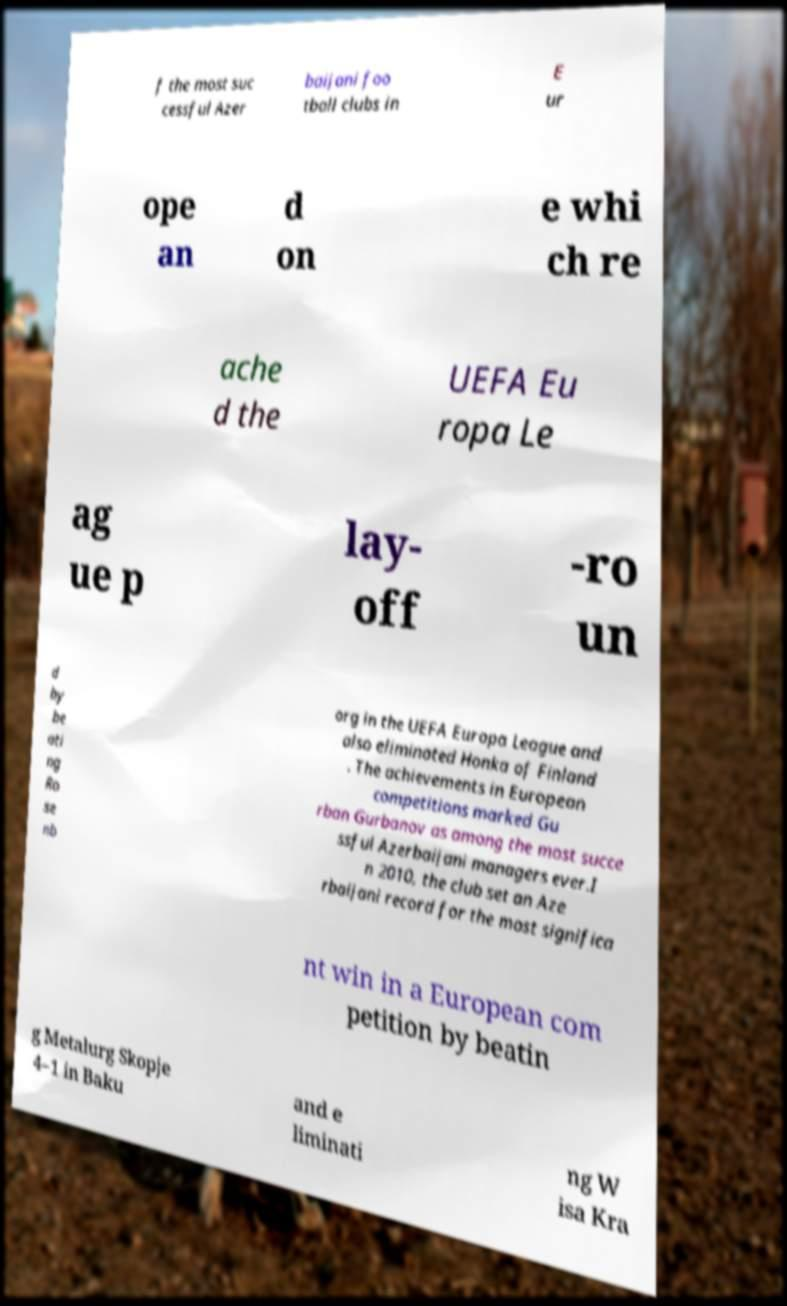For documentation purposes, I need the text within this image transcribed. Could you provide that? f the most suc cessful Azer baijani foo tball clubs in E ur ope an d on e whi ch re ache d the UEFA Eu ropa Le ag ue p lay- off -ro un d by be ati ng Ro se nb org in the UEFA Europa League and also eliminated Honka of Finland . The achievements in European competitions marked Gu rban Gurbanov as among the most succe ssful Azerbaijani managers ever.I n 2010, the club set an Aze rbaijani record for the most significa nt win in a European com petition by beatin g Metalurg Skopje 4–1 in Baku and e liminati ng W isa Kra 